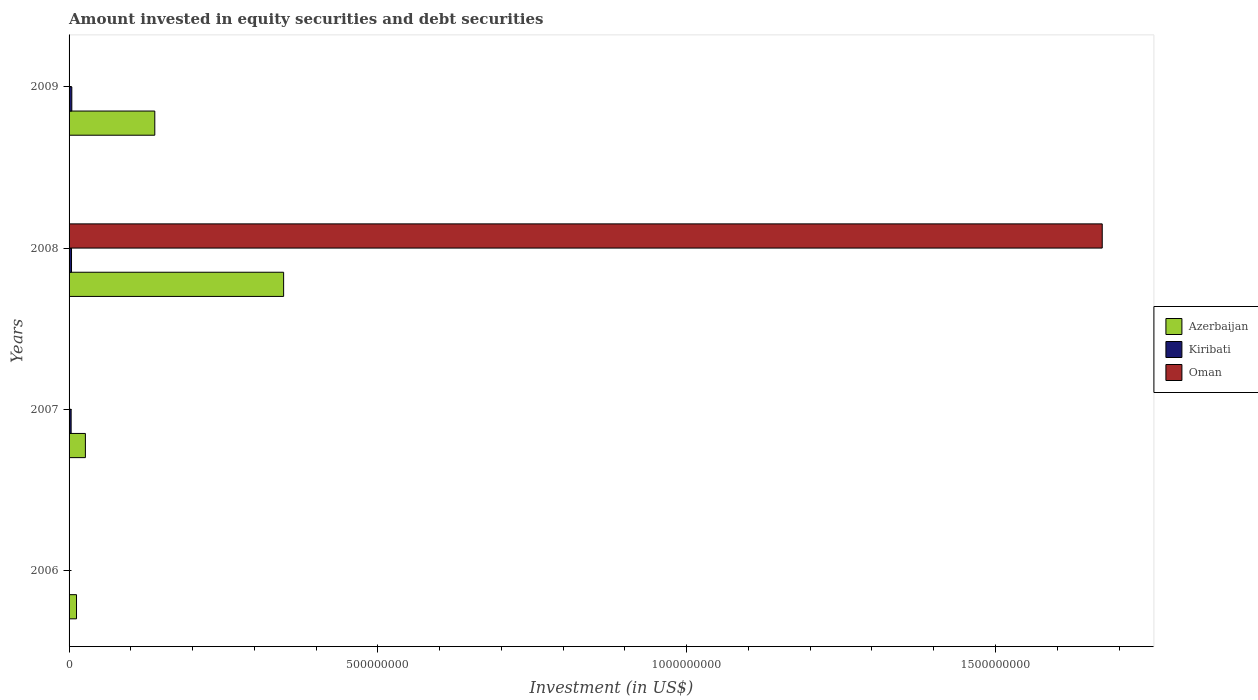How many different coloured bars are there?
Ensure brevity in your answer.  3. How many bars are there on the 1st tick from the top?
Keep it short and to the point. 2. How many bars are there on the 3rd tick from the bottom?
Your answer should be compact. 3. What is the label of the 2nd group of bars from the top?
Provide a short and direct response. 2008. In how many cases, is the number of bars for a given year not equal to the number of legend labels?
Make the answer very short. 3. What is the amount invested in equity securities and debt securities in Kiribati in 2006?
Ensure brevity in your answer.  0. Across all years, what is the maximum amount invested in equity securities and debt securities in Azerbaijan?
Give a very brief answer. 3.47e+08. What is the total amount invested in equity securities and debt securities in Azerbaijan in the graph?
Offer a terse response. 5.25e+08. What is the difference between the amount invested in equity securities and debt securities in Kiribati in 2007 and that in 2009?
Ensure brevity in your answer.  -1.09e+06. What is the difference between the amount invested in equity securities and debt securities in Kiribati in 2006 and the amount invested in equity securities and debt securities in Oman in 2009?
Your answer should be very brief. 0. What is the average amount invested in equity securities and debt securities in Kiribati per year?
Offer a terse response. 2.94e+06. In the year 2008, what is the difference between the amount invested in equity securities and debt securities in Azerbaijan and amount invested in equity securities and debt securities in Oman?
Provide a short and direct response. -1.33e+09. In how many years, is the amount invested in equity securities and debt securities in Azerbaijan greater than 1000000000 US$?
Your answer should be very brief. 0. What is the ratio of the amount invested in equity securities and debt securities in Kiribati in 2008 to that in 2009?
Give a very brief answer. 0.89. Is the amount invested in equity securities and debt securities in Azerbaijan in 2008 less than that in 2009?
Offer a terse response. No. What is the difference between the highest and the second highest amount invested in equity securities and debt securities in Kiribati?
Offer a terse response. 4.67e+05. What is the difference between the highest and the lowest amount invested in equity securities and debt securities in Kiribati?
Offer a very short reply. 4.43e+06. In how many years, is the amount invested in equity securities and debt securities in Oman greater than the average amount invested in equity securities and debt securities in Oman taken over all years?
Provide a succinct answer. 1. Is the sum of the amount invested in equity securities and debt securities in Azerbaijan in 2008 and 2009 greater than the maximum amount invested in equity securities and debt securities in Kiribati across all years?
Your answer should be compact. Yes. Is it the case that in every year, the sum of the amount invested in equity securities and debt securities in Oman and amount invested in equity securities and debt securities in Azerbaijan is greater than the amount invested in equity securities and debt securities in Kiribati?
Offer a very short reply. Yes. Are all the bars in the graph horizontal?
Your response must be concise. Yes. What is the difference between two consecutive major ticks on the X-axis?
Provide a succinct answer. 5.00e+08. Does the graph contain any zero values?
Your response must be concise. Yes. Where does the legend appear in the graph?
Your answer should be very brief. Center right. What is the title of the graph?
Ensure brevity in your answer.  Amount invested in equity securities and debt securities. What is the label or title of the X-axis?
Offer a very short reply. Investment (in US$). What is the label or title of the Y-axis?
Provide a short and direct response. Years. What is the Investment (in US$) in Azerbaijan in 2006?
Make the answer very short. 1.20e+07. What is the Investment (in US$) in Azerbaijan in 2007?
Your response must be concise. 2.64e+07. What is the Investment (in US$) in Kiribati in 2007?
Provide a short and direct response. 3.34e+06. What is the Investment (in US$) in Oman in 2007?
Your response must be concise. 0. What is the Investment (in US$) in Azerbaijan in 2008?
Provide a short and direct response. 3.47e+08. What is the Investment (in US$) in Kiribati in 2008?
Provide a succinct answer. 3.97e+06. What is the Investment (in US$) in Oman in 2008?
Make the answer very short. 1.67e+09. What is the Investment (in US$) of Azerbaijan in 2009?
Offer a terse response. 1.39e+08. What is the Investment (in US$) of Kiribati in 2009?
Ensure brevity in your answer.  4.43e+06. What is the Investment (in US$) in Oman in 2009?
Give a very brief answer. 0. Across all years, what is the maximum Investment (in US$) of Azerbaijan?
Your answer should be very brief. 3.47e+08. Across all years, what is the maximum Investment (in US$) in Kiribati?
Make the answer very short. 4.43e+06. Across all years, what is the maximum Investment (in US$) of Oman?
Your answer should be very brief. 1.67e+09. Across all years, what is the minimum Investment (in US$) of Azerbaijan?
Ensure brevity in your answer.  1.20e+07. Across all years, what is the minimum Investment (in US$) in Kiribati?
Provide a succinct answer. 0. What is the total Investment (in US$) in Azerbaijan in the graph?
Give a very brief answer. 5.25e+08. What is the total Investment (in US$) in Kiribati in the graph?
Offer a very short reply. 1.17e+07. What is the total Investment (in US$) in Oman in the graph?
Offer a very short reply. 1.67e+09. What is the difference between the Investment (in US$) in Azerbaijan in 2006 and that in 2007?
Your answer should be very brief. -1.44e+07. What is the difference between the Investment (in US$) in Azerbaijan in 2006 and that in 2008?
Offer a terse response. -3.35e+08. What is the difference between the Investment (in US$) in Azerbaijan in 2006 and that in 2009?
Provide a succinct answer. -1.27e+08. What is the difference between the Investment (in US$) in Azerbaijan in 2007 and that in 2008?
Your response must be concise. -3.21e+08. What is the difference between the Investment (in US$) of Kiribati in 2007 and that in 2008?
Keep it short and to the point. -6.28e+05. What is the difference between the Investment (in US$) in Azerbaijan in 2007 and that in 2009?
Offer a terse response. -1.12e+08. What is the difference between the Investment (in US$) of Kiribati in 2007 and that in 2009?
Your response must be concise. -1.09e+06. What is the difference between the Investment (in US$) in Azerbaijan in 2008 and that in 2009?
Give a very brief answer. 2.09e+08. What is the difference between the Investment (in US$) in Kiribati in 2008 and that in 2009?
Provide a succinct answer. -4.67e+05. What is the difference between the Investment (in US$) in Azerbaijan in 2006 and the Investment (in US$) in Kiribati in 2007?
Offer a very short reply. 8.71e+06. What is the difference between the Investment (in US$) of Azerbaijan in 2006 and the Investment (in US$) of Kiribati in 2008?
Make the answer very short. 8.08e+06. What is the difference between the Investment (in US$) of Azerbaijan in 2006 and the Investment (in US$) of Oman in 2008?
Your response must be concise. -1.66e+09. What is the difference between the Investment (in US$) of Azerbaijan in 2006 and the Investment (in US$) of Kiribati in 2009?
Your answer should be very brief. 7.61e+06. What is the difference between the Investment (in US$) in Azerbaijan in 2007 and the Investment (in US$) in Kiribati in 2008?
Make the answer very short. 2.25e+07. What is the difference between the Investment (in US$) in Azerbaijan in 2007 and the Investment (in US$) in Oman in 2008?
Make the answer very short. -1.65e+09. What is the difference between the Investment (in US$) in Kiribati in 2007 and the Investment (in US$) in Oman in 2008?
Offer a terse response. -1.67e+09. What is the difference between the Investment (in US$) in Azerbaijan in 2007 and the Investment (in US$) in Kiribati in 2009?
Provide a succinct answer. 2.20e+07. What is the difference between the Investment (in US$) of Azerbaijan in 2008 and the Investment (in US$) of Kiribati in 2009?
Offer a terse response. 3.43e+08. What is the average Investment (in US$) in Azerbaijan per year?
Provide a short and direct response. 1.31e+08. What is the average Investment (in US$) of Kiribati per year?
Provide a short and direct response. 2.94e+06. What is the average Investment (in US$) of Oman per year?
Make the answer very short. 4.18e+08. In the year 2007, what is the difference between the Investment (in US$) of Azerbaijan and Investment (in US$) of Kiribati?
Offer a very short reply. 2.31e+07. In the year 2008, what is the difference between the Investment (in US$) in Azerbaijan and Investment (in US$) in Kiribati?
Offer a very short reply. 3.43e+08. In the year 2008, what is the difference between the Investment (in US$) of Azerbaijan and Investment (in US$) of Oman?
Your answer should be very brief. -1.33e+09. In the year 2008, what is the difference between the Investment (in US$) in Kiribati and Investment (in US$) in Oman?
Offer a very short reply. -1.67e+09. In the year 2009, what is the difference between the Investment (in US$) of Azerbaijan and Investment (in US$) of Kiribati?
Ensure brevity in your answer.  1.34e+08. What is the ratio of the Investment (in US$) in Azerbaijan in 2006 to that in 2007?
Provide a succinct answer. 0.46. What is the ratio of the Investment (in US$) in Azerbaijan in 2006 to that in 2008?
Keep it short and to the point. 0.03. What is the ratio of the Investment (in US$) in Azerbaijan in 2006 to that in 2009?
Your response must be concise. 0.09. What is the ratio of the Investment (in US$) in Azerbaijan in 2007 to that in 2008?
Your answer should be very brief. 0.08. What is the ratio of the Investment (in US$) of Kiribati in 2007 to that in 2008?
Provide a succinct answer. 0.84. What is the ratio of the Investment (in US$) in Azerbaijan in 2007 to that in 2009?
Offer a terse response. 0.19. What is the ratio of the Investment (in US$) in Kiribati in 2007 to that in 2009?
Provide a short and direct response. 0.75. What is the ratio of the Investment (in US$) of Azerbaijan in 2008 to that in 2009?
Keep it short and to the point. 2.5. What is the ratio of the Investment (in US$) in Kiribati in 2008 to that in 2009?
Ensure brevity in your answer.  0.89. What is the difference between the highest and the second highest Investment (in US$) in Azerbaijan?
Give a very brief answer. 2.09e+08. What is the difference between the highest and the second highest Investment (in US$) of Kiribati?
Ensure brevity in your answer.  4.67e+05. What is the difference between the highest and the lowest Investment (in US$) in Azerbaijan?
Make the answer very short. 3.35e+08. What is the difference between the highest and the lowest Investment (in US$) of Kiribati?
Provide a succinct answer. 4.43e+06. What is the difference between the highest and the lowest Investment (in US$) in Oman?
Your answer should be compact. 1.67e+09. 